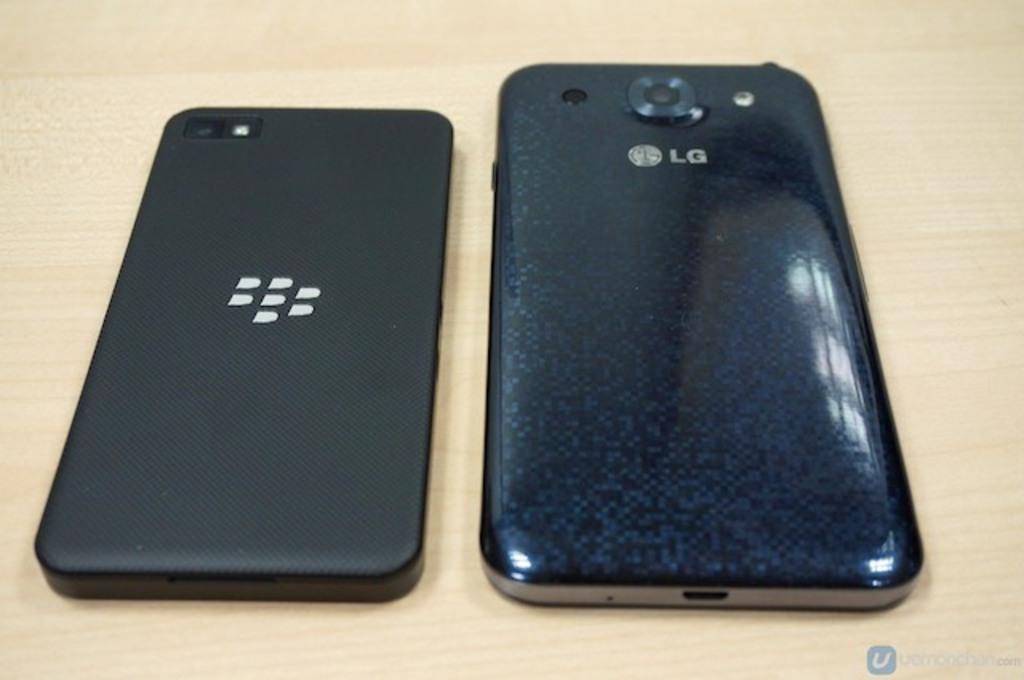What is the brand of the phone?
Provide a succinct answer. Lg. 